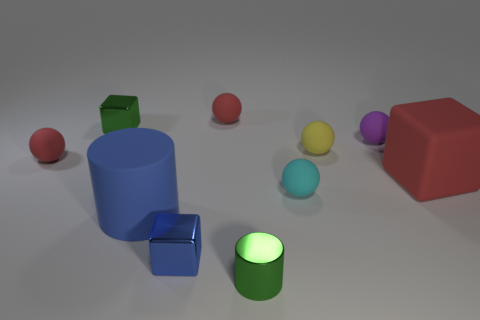Subtract all red spheres. How many spheres are left? 3 Subtract all cyan cylinders. How many red spheres are left? 2 Subtract all blue cubes. How many cubes are left? 2 Subtract 3 spheres. How many spheres are left? 2 Subtract all cubes. How many objects are left? 7 Subtract all blue cylinders. Subtract all gray balls. How many cylinders are left? 1 Subtract all tiny blue cubes. Subtract all green shiny cubes. How many objects are left? 8 Add 7 red matte cubes. How many red matte cubes are left? 8 Add 6 red spheres. How many red spheres exist? 8 Subtract 0 gray blocks. How many objects are left? 10 